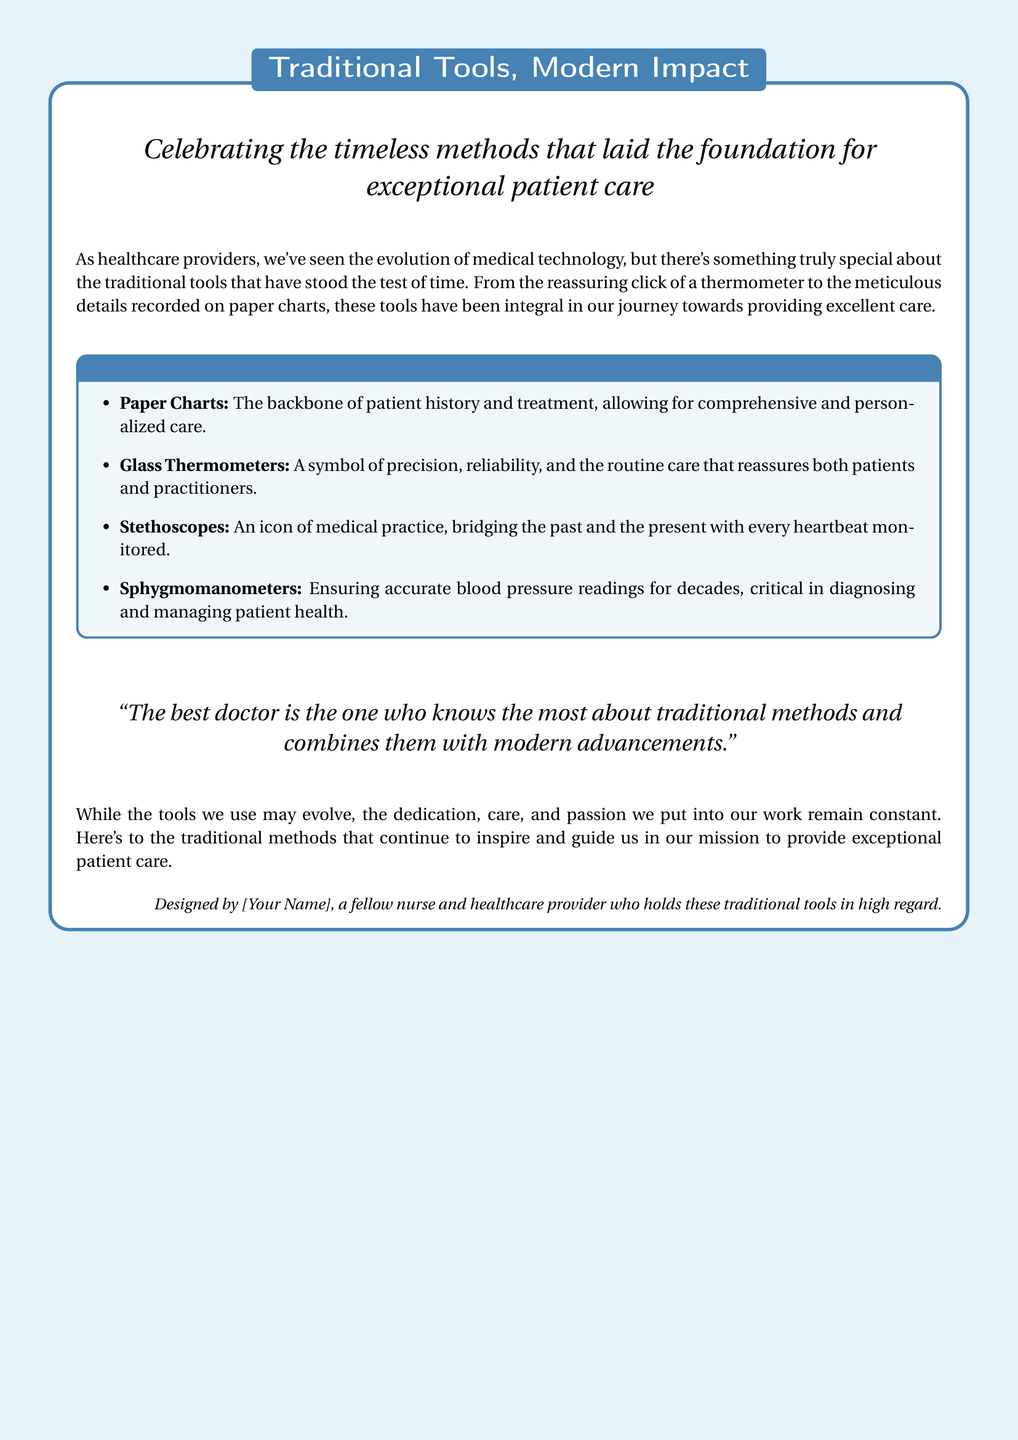What is the title of the greeting card? The title appears at the top of the card, stating the main theme.
Answer: Traditional Tools, Modern Impact How many traditional medical tools are listed? The number of items in the 'Traditional Medical Tools' section indicates the count of tools.
Answer: Four What is one function of paper charts mentioned in the card? The card describes the purpose of paper charts in the context of patient care.
Answer: Comprehensive and personalized care Which medical tool is described as a symbol of precision? The card specifically labels one tool as a symbol of precision.
Answer: Glass Thermometers What quote is included in the card? The card features a quote about combining traditional methods with modern advancements.
Answer: "The best doctor is the one who knows the most about traditional methods and combines them with modern advancements." Who designed the greeting card? The last section of the card credits the designer of the card.
Answer: [Your Name] 